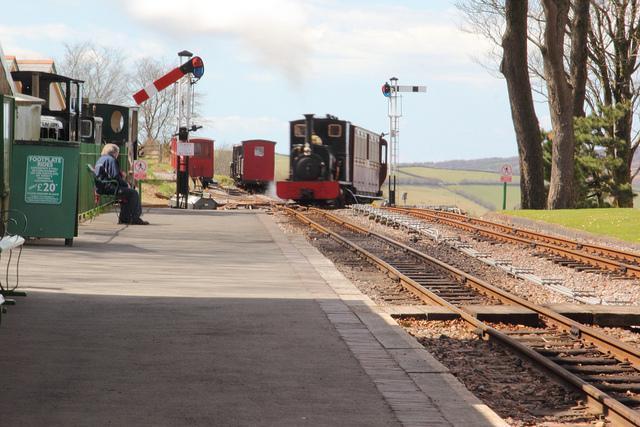How many people are on the platform?
Give a very brief answer. 1. How many tracks run here?
Give a very brief answer. 2. How many trains are visible?
Give a very brief answer. 2. 